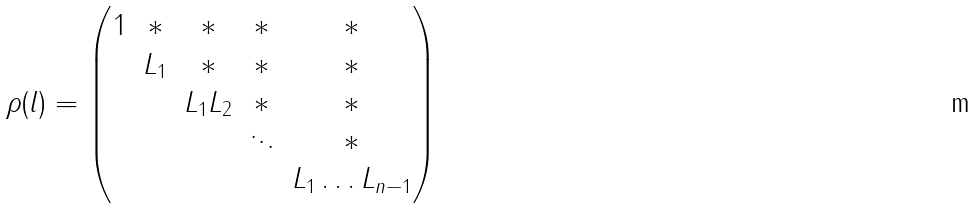<formula> <loc_0><loc_0><loc_500><loc_500>\rho ( l ) = \begin{pmatrix} 1 & * & * & * & * \\ & L _ { 1 } & * & * & * \\ & & L _ { 1 } L _ { 2 } & * & * \\ & & & \ddots & * \\ & & & & L _ { 1 } \dots L _ { n - 1 } \end{pmatrix}</formula> 